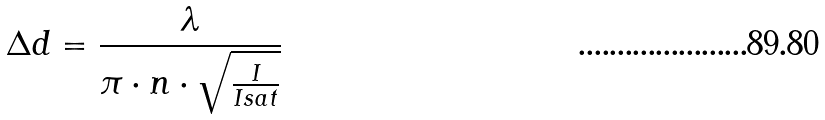Convert formula to latex. <formula><loc_0><loc_0><loc_500><loc_500>\Delta d = \frac { \lambda } { \pi \cdot n \cdot \sqrt { \frac { I } { I s a t } } }</formula> 